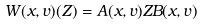Convert formula to latex. <formula><loc_0><loc_0><loc_500><loc_500>W ( x , v ) ( Z ) = A ( x , v ) Z B ( x , v )</formula> 